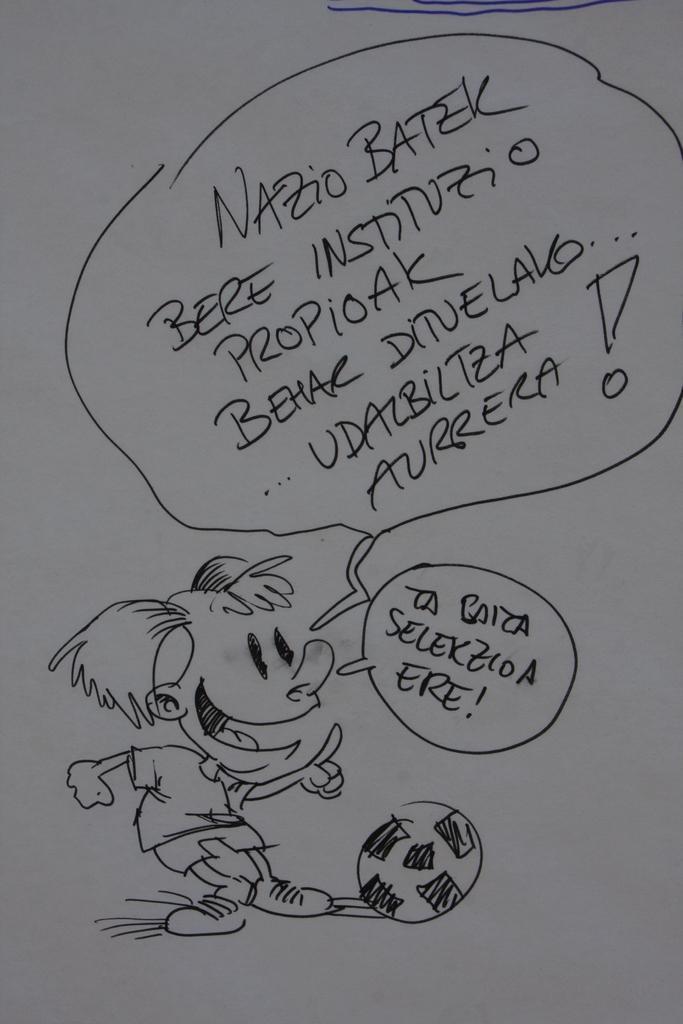How would you summarize this image in a sentence or two? In this image we can see a paper and on the paper we can see the drawing of a ball and also a person. We can also see the text. 